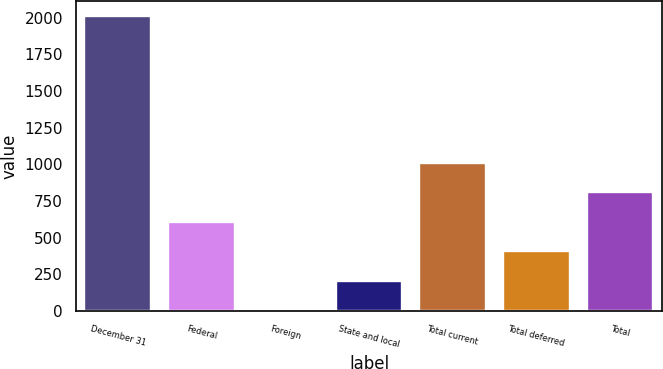Convert chart. <chart><loc_0><loc_0><loc_500><loc_500><bar_chart><fcel>December 31<fcel>Federal<fcel>Foreign<fcel>State and local<fcel>Total current<fcel>Total deferred<fcel>Total<nl><fcel>2013<fcel>608.1<fcel>6<fcel>206.7<fcel>1009.5<fcel>407.4<fcel>808.8<nl></chart> 